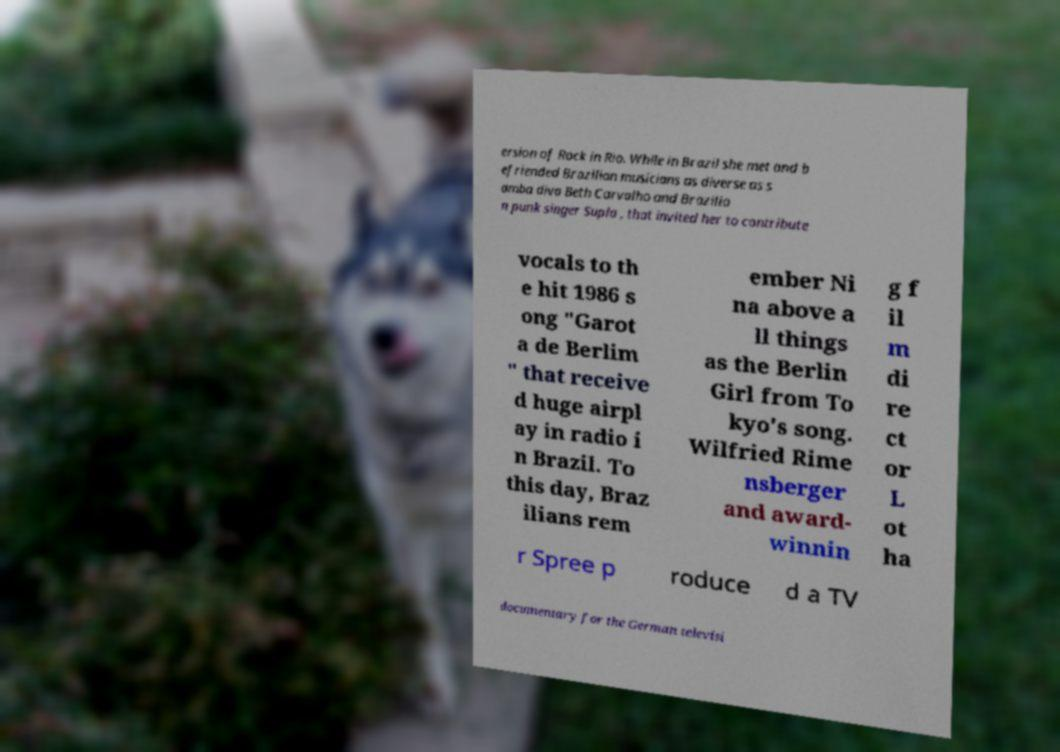Could you extract and type out the text from this image? ersion of Rock in Rio. While in Brazil she met and b efriended Brazilian musicians as diverse as s amba diva Beth Carvalho and Brazilia n punk singer Supla , that invited her to contribute vocals to th e hit 1986 s ong "Garot a de Berlim " that receive d huge airpl ay in radio i n Brazil. To this day, Braz ilians rem ember Ni na above a ll things as the Berlin Girl from To kyo's song. Wilfried Rime nsberger and award- winnin g f il m di re ct or L ot ha r Spree p roduce d a TV documentary for the German televisi 